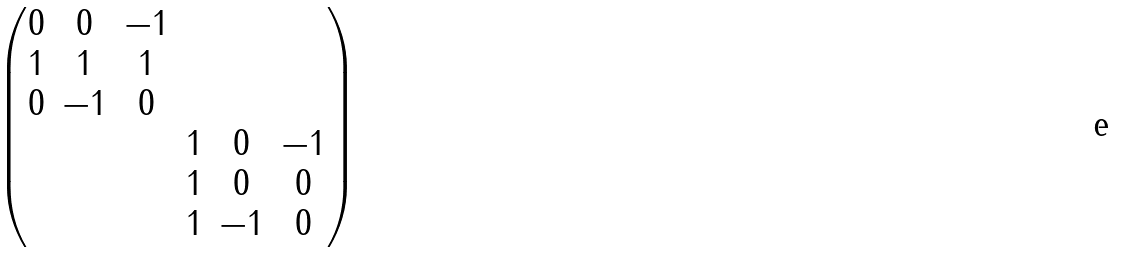Convert formula to latex. <formula><loc_0><loc_0><loc_500><loc_500>\begin{pmatrix} 0 & 0 & - 1 & & & \\ 1 & 1 & 1 & & & \\ 0 & - 1 & 0 & & & \\ & & & 1 & 0 & - 1 \\ & & & 1 & 0 & 0 \\ & & & 1 & - 1 & 0 \end{pmatrix}</formula> 